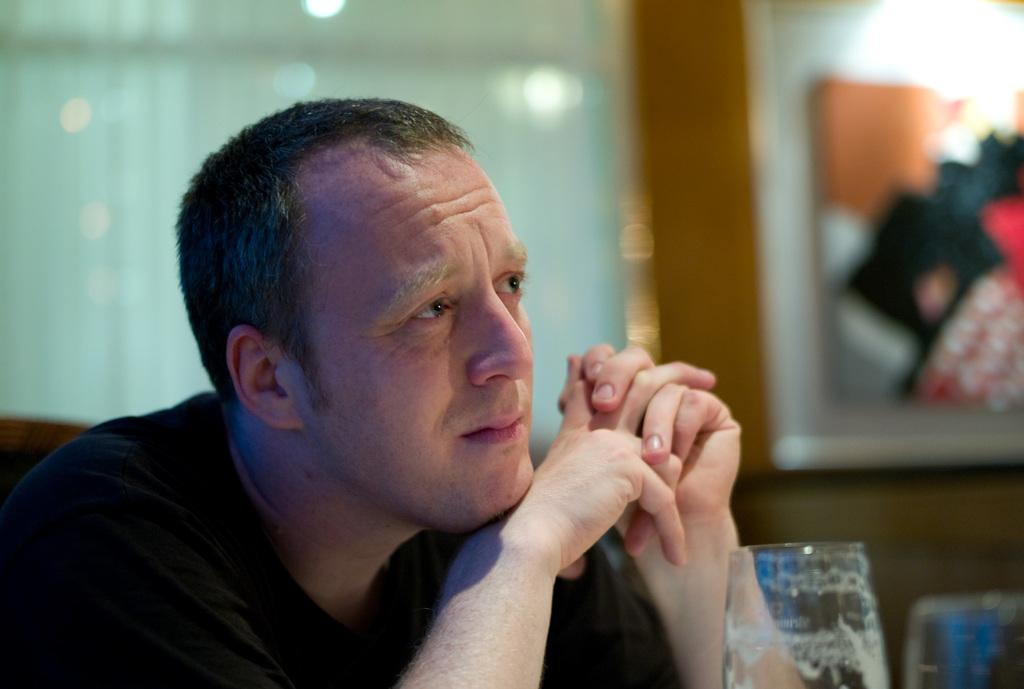Who is present in the image? There is a man in the image. What is in front of the man? There are glasses in front of the man. What is behind the man? There is a wall behind the man. What is on the wall? There are window blinds and a picture frame on the wall. What type of waves can be seen crashing against the church in the image? There is no church or waves present in the image. 